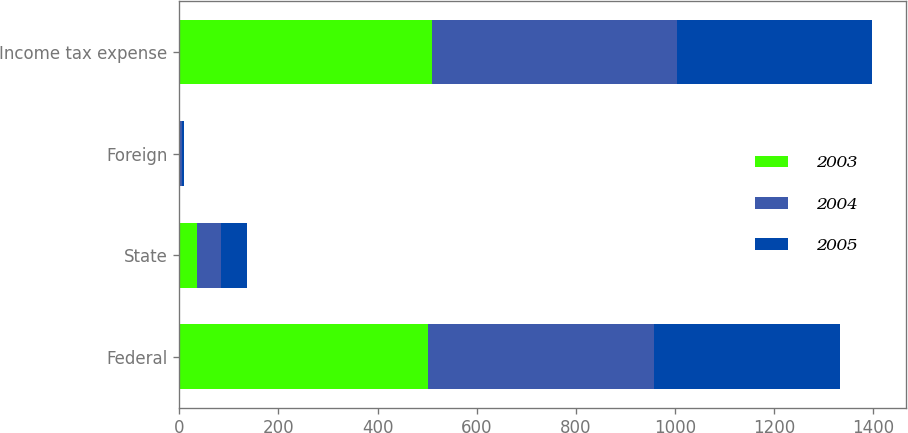Convert chart. <chart><loc_0><loc_0><loc_500><loc_500><stacked_bar_chart><ecel><fcel>Federal<fcel>State<fcel>Foreign<fcel>Income tax expense<nl><fcel>2003<fcel>502<fcel>36<fcel>1<fcel>509<nl><fcel>2004<fcel>456<fcel>49<fcel>5<fcel>496<nl><fcel>2005<fcel>375<fcel>51<fcel>3<fcel>392<nl></chart> 